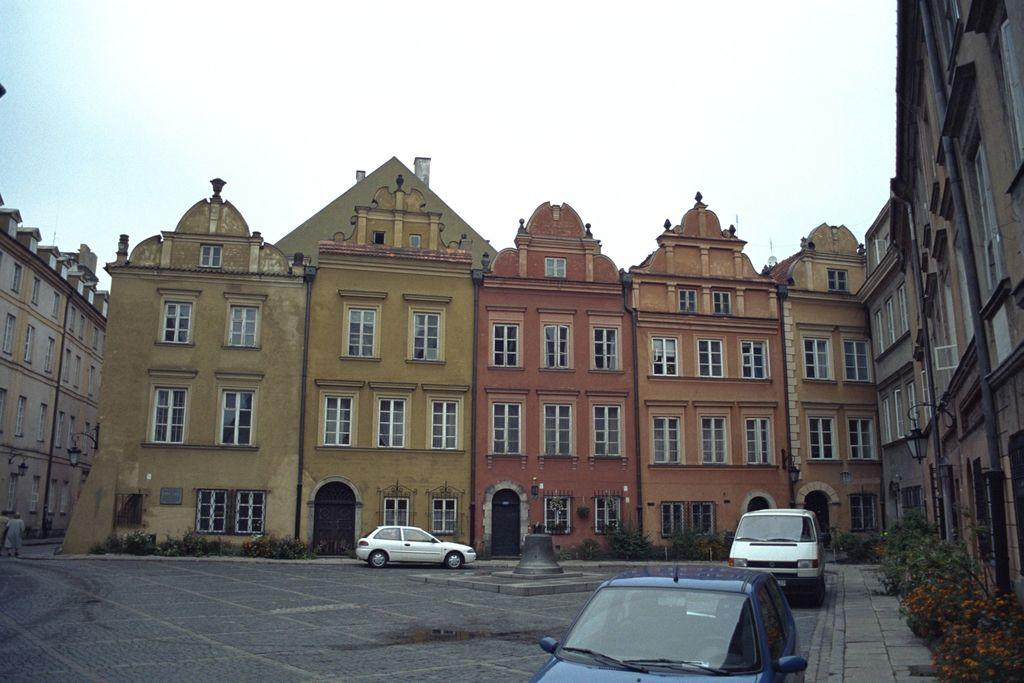What type of living organisms can be seen in the image? Plants can be seen in the image. What type of structures are present in the image? Buildings are present in the image. What type of vehicles are at the bottom of the image? Cars are at the bottom of the image. What is visible at the top of the image? The sky is visible at the top of the image. Can you tell me how many goats are depicted in the image? There are no goats present in the image. What type of underwear is visible on the buildings in the image? There is no underwear visible in the image, as it features plants, buildings, cars, and the sky. What acoustics can be heard from the buildings in the image? The image does not provide any information about the acoustics of the buildings. 